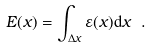<formula> <loc_0><loc_0><loc_500><loc_500>E ( x ) = \int _ { \Delta x } \varepsilon ( x ) { \mathrm d } x \ .</formula> 